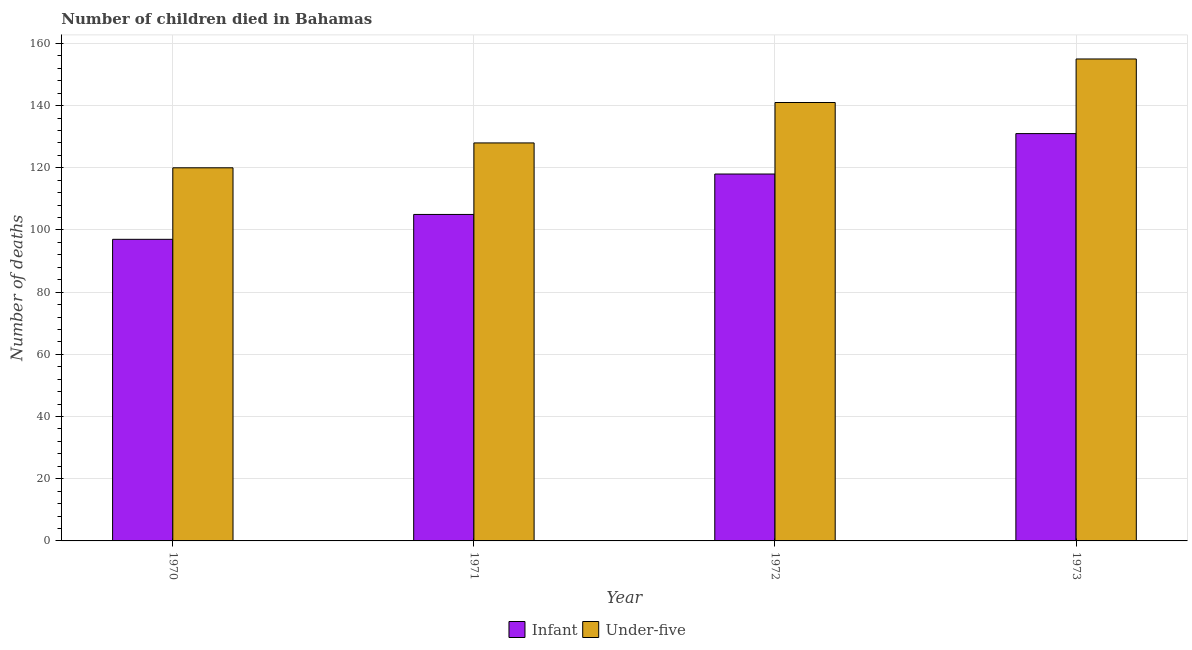How many different coloured bars are there?
Offer a very short reply. 2. How many groups of bars are there?
Provide a succinct answer. 4. Are the number of bars on each tick of the X-axis equal?
Your response must be concise. Yes. How many bars are there on the 2nd tick from the left?
Provide a succinct answer. 2. What is the number of infant deaths in 1971?
Give a very brief answer. 105. Across all years, what is the maximum number of under-five deaths?
Your response must be concise. 155. Across all years, what is the minimum number of infant deaths?
Ensure brevity in your answer.  97. In which year was the number of under-five deaths maximum?
Your answer should be compact. 1973. In which year was the number of under-five deaths minimum?
Offer a terse response. 1970. What is the total number of under-five deaths in the graph?
Offer a very short reply. 544. What is the difference between the number of under-five deaths in 1971 and that in 1973?
Make the answer very short. -27. What is the difference between the number of under-five deaths in 1972 and the number of infant deaths in 1970?
Offer a very short reply. 21. What is the average number of under-five deaths per year?
Offer a terse response. 136. In how many years, is the number of infant deaths greater than 20?
Give a very brief answer. 4. What is the ratio of the number of infant deaths in 1971 to that in 1973?
Ensure brevity in your answer.  0.8. What is the difference between the highest and the lowest number of under-five deaths?
Ensure brevity in your answer.  35. What does the 2nd bar from the left in 1972 represents?
Your answer should be very brief. Under-five. What does the 1st bar from the right in 1970 represents?
Ensure brevity in your answer.  Under-five. Are all the bars in the graph horizontal?
Provide a succinct answer. No. Are the values on the major ticks of Y-axis written in scientific E-notation?
Your response must be concise. No. Does the graph contain grids?
Provide a short and direct response. Yes. How many legend labels are there?
Offer a terse response. 2. What is the title of the graph?
Ensure brevity in your answer.  Number of children died in Bahamas. Does "Infant" appear as one of the legend labels in the graph?
Your response must be concise. Yes. What is the label or title of the Y-axis?
Provide a succinct answer. Number of deaths. What is the Number of deaths in Infant in 1970?
Your answer should be very brief. 97. What is the Number of deaths of Under-five in 1970?
Offer a terse response. 120. What is the Number of deaths of Infant in 1971?
Give a very brief answer. 105. What is the Number of deaths of Under-five in 1971?
Make the answer very short. 128. What is the Number of deaths in Infant in 1972?
Offer a very short reply. 118. What is the Number of deaths in Under-five in 1972?
Provide a short and direct response. 141. What is the Number of deaths of Infant in 1973?
Your answer should be compact. 131. What is the Number of deaths of Under-five in 1973?
Make the answer very short. 155. Across all years, what is the maximum Number of deaths of Infant?
Your answer should be very brief. 131. Across all years, what is the maximum Number of deaths of Under-five?
Ensure brevity in your answer.  155. Across all years, what is the minimum Number of deaths in Infant?
Offer a terse response. 97. Across all years, what is the minimum Number of deaths in Under-five?
Provide a short and direct response. 120. What is the total Number of deaths in Infant in the graph?
Ensure brevity in your answer.  451. What is the total Number of deaths in Under-five in the graph?
Your response must be concise. 544. What is the difference between the Number of deaths of Infant in 1970 and that in 1971?
Your answer should be very brief. -8. What is the difference between the Number of deaths in Infant in 1970 and that in 1973?
Keep it short and to the point. -34. What is the difference between the Number of deaths in Under-five in 1970 and that in 1973?
Offer a very short reply. -35. What is the difference between the Number of deaths in Under-five in 1971 and that in 1972?
Ensure brevity in your answer.  -13. What is the difference between the Number of deaths in Infant in 1970 and the Number of deaths in Under-five in 1971?
Your answer should be compact. -31. What is the difference between the Number of deaths in Infant in 1970 and the Number of deaths in Under-five in 1972?
Keep it short and to the point. -44. What is the difference between the Number of deaths in Infant in 1970 and the Number of deaths in Under-five in 1973?
Give a very brief answer. -58. What is the difference between the Number of deaths in Infant in 1971 and the Number of deaths in Under-five in 1972?
Give a very brief answer. -36. What is the difference between the Number of deaths in Infant in 1971 and the Number of deaths in Under-five in 1973?
Offer a very short reply. -50. What is the difference between the Number of deaths in Infant in 1972 and the Number of deaths in Under-five in 1973?
Your answer should be compact. -37. What is the average Number of deaths in Infant per year?
Offer a very short reply. 112.75. What is the average Number of deaths of Under-five per year?
Provide a short and direct response. 136. In the year 1970, what is the difference between the Number of deaths in Infant and Number of deaths in Under-five?
Provide a succinct answer. -23. In the year 1971, what is the difference between the Number of deaths in Infant and Number of deaths in Under-five?
Your answer should be compact. -23. In the year 1973, what is the difference between the Number of deaths of Infant and Number of deaths of Under-five?
Give a very brief answer. -24. What is the ratio of the Number of deaths in Infant in 1970 to that in 1971?
Your answer should be very brief. 0.92. What is the ratio of the Number of deaths in Infant in 1970 to that in 1972?
Offer a terse response. 0.82. What is the ratio of the Number of deaths of Under-five in 1970 to that in 1972?
Offer a very short reply. 0.85. What is the ratio of the Number of deaths of Infant in 1970 to that in 1973?
Give a very brief answer. 0.74. What is the ratio of the Number of deaths of Under-five in 1970 to that in 1973?
Your answer should be compact. 0.77. What is the ratio of the Number of deaths in Infant in 1971 to that in 1972?
Offer a very short reply. 0.89. What is the ratio of the Number of deaths in Under-five in 1971 to that in 1972?
Provide a short and direct response. 0.91. What is the ratio of the Number of deaths in Infant in 1971 to that in 1973?
Your response must be concise. 0.8. What is the ratio of the Number of deaths in Under-five in 1971 to that in 1973?
Keep it short and to the point. 0.83. What is the ratio of the Number of deaths in Infant in 1972 to that in 1973?
Make the answer very short. 0.9. What is the ratio of the Number of deaths in Under-five in 1972 to that in 1973?
Give a very brief answer. 0.91. What is the difference between the highest and the second highest Number of deaths in Infant?
Provide a succinct answer. 13. What is the difference between the highest and the second highest Number of deaths in Under-five?
Your answer should be compact. 14. What is the difference between the highest and the lowest Number of deaths in Under-five?
Ensure brevity in your answer.  35. 